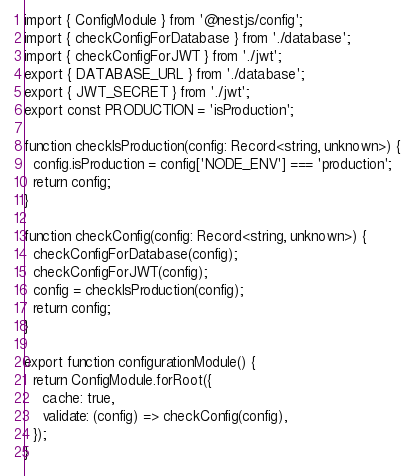<code> <loc_0><loc_0><loc_500><loc_500><_TypeScript_>import { ConfigModule } from '@nestjs/config';
import { checkConfigForDatabase } from './database';
import { checkConfigForJWT } from './jwt';
export { DATABASE_URL } from './database';
export { JWT_SECRET } from './jwt';
export const PRODUCTION = 'isProduction';

function checkIsProduction(config: Record<string, unknown>) {
  config.isProduction = config['NODE_ENV'] === 'production';
  return config;
}

function checkConfig(config: Record<string, unknown>) {
  checkConfigForDatabase(config);
  checkConfigForJWT(config);
  config = checkIsProduction(config);
  return config;
}

export function configurationModule() {
  return ConfigModule.forRoot({
    cache: true,
    validate: (config) => checkConfig(config),
  });
}
</code> 